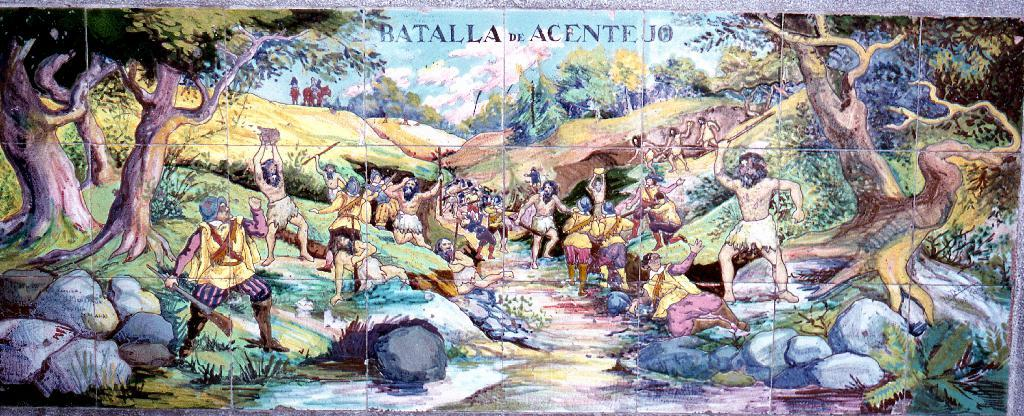What is the main subject of the image? The main subject of the image is a picture of animations. What type of natural elements can be seen in the image? There are trees and rocks in the image. Can you describe the presence of other people in the image? Yes, there are many other people in the image. How does the beginner adjust their crying in the image? There is no beginner or crying present in the image; it features a picture of animations, trees, rocks, and other people. 